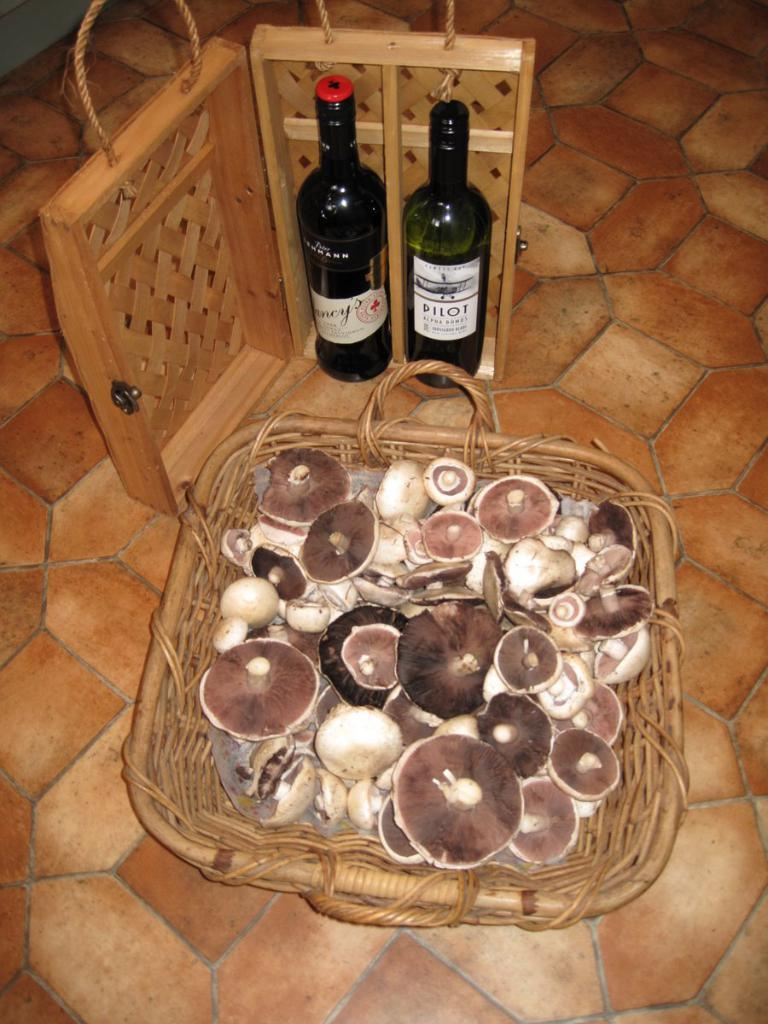Provide a one-sentence caption for the provided image. Bottle of Pilot Wine and Bottle of Nancy's wine. 